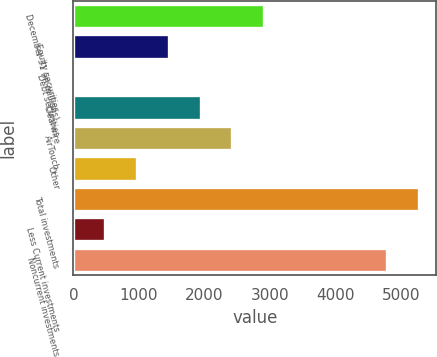Convert chart to OTSL. <chart><loc_0><loc_0><loc_500><loc_500><bar_chart><fcel>December 31 (in millions)<fcel>Equity securities<fcel>Debt securities<fcel>Clearwire<fcel>AirTouch<fcel>Other<fcel>Total investments<fcel>Less Current investments<fcel>Noncurrent investments<nl><fcel>2906.4<fcel>1454.7<fcel>3<fcel>1938.6<fcel>2422.5<fcel>970.8<fcel>5266.9<fcel>486.9<fcel>4783<nl></chart> 